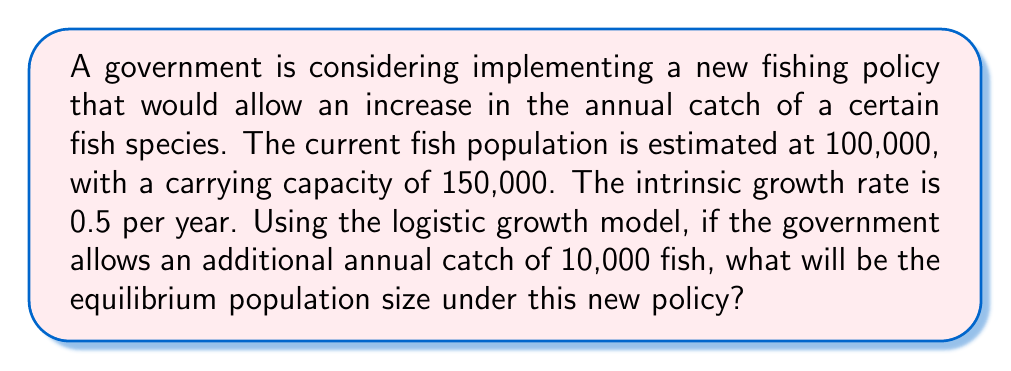What is the answer to this math problem? To solve this problem, we'll use the logistic growth model with harvesting. The model is given by:

$$\frac{dN}{dt} = rN(1-\frac{N}{K}) - H$$

Where:
$N$ = population size
$r$ = intrinsic growth rate
$K$ = carrying capacity
$H$ = harvesting rate (annual catch)

At equilibrium, $\frac{dN}{dt} = 0$, so we can set up the equation:

$$0 = rN(1-\frac{N}{K}) - H$$

Rearranging this equation:

$$rN(1-\frac{N}{K}) = H$$

$$rN - \frac{rN^2}{K} = H$$

Multiplying both sides by $K$:

$$rNK - rN^2 = HK$$

This can be written as a quadratic equation:

$$rN^2 - rNK + HK = 0$$

Substituting the given values:
$r = 0.5$
$K = 150,000$
$H = 10,000$

We get:

$$0.5N^2 - 0.5(150,000)N + 10,000(150,000) = 0$$

Simplifying:

$$N^2 - 300,000N + 3,000,000,000 = 0$$

Using the quadratic formula $N = \frac{-b \pm \sqrt{b^2 - 4ac}}{2a}$, we can solve for N:

$$N = \frac{300,000 \pm \sqrt{90,000,000,000 - 12,000,000,000}}{2}$$

$$N = \frac{300,000 \pm \sqrt{78,000,000,000}}{2}$$

$$N = \frac{300,000 \pm 279,285}{2}$$

This gives us two solutions:
$N_1 = 289,643$ (rounded to nearest whole fish)
$N_2 = 10,357$ (rounded to nearest whole fish)

The larger value, 289,643, is not biologically realistic as it exceeds the carrying capacity. Therefore, the equilibrium population size under the new policy will be approximately 10,357 fish.
Answer: The equilibrium population size under the new fishing policy will be approximately 10,357 fish. 